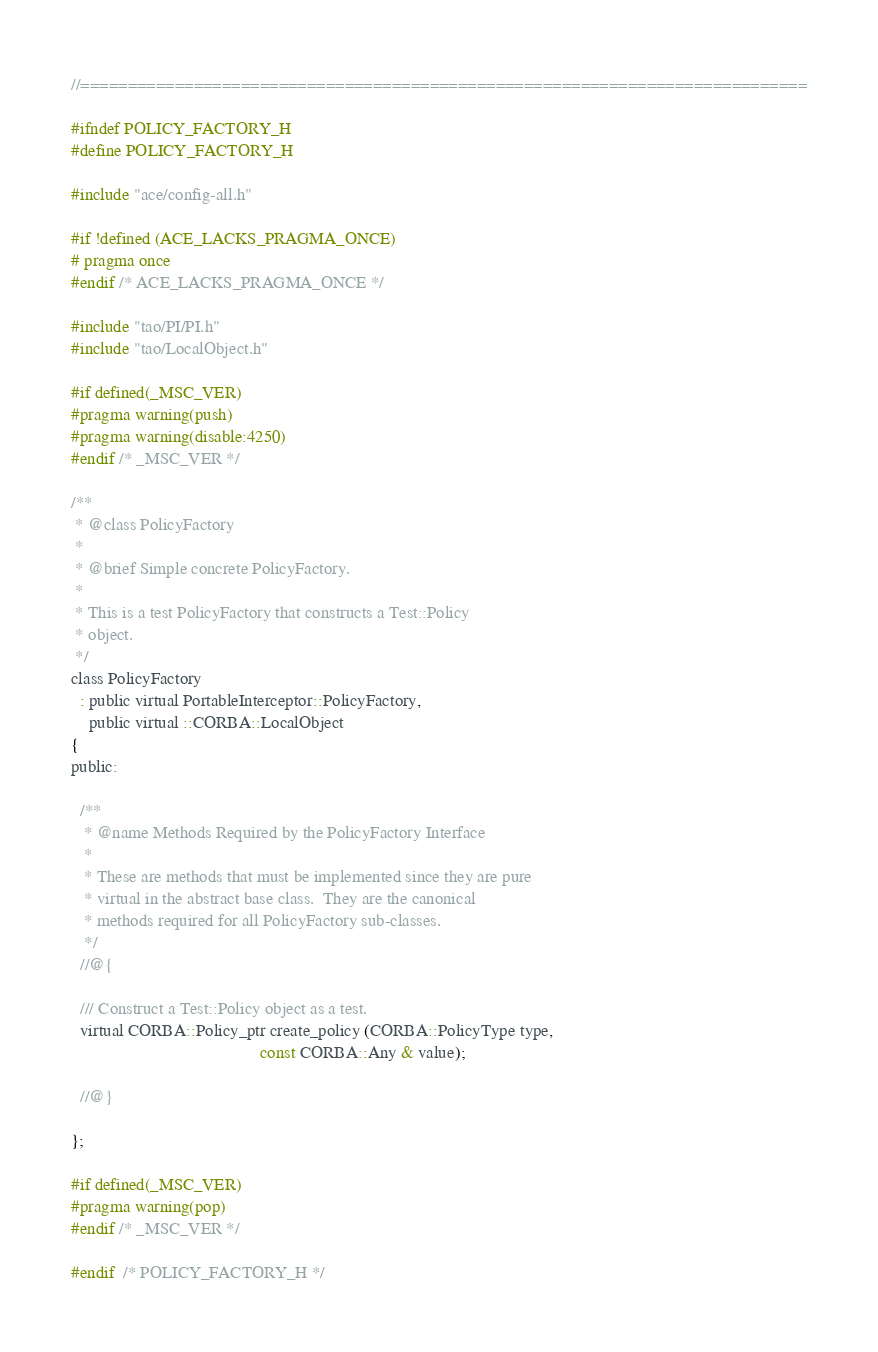<code> <loc_0><loc_0><loc_500><loc_500><_C_>//=============================================================================

#ifndef POLICY_FACTORY_H
#define POLICY_FACTORY_H

#include "ace/config-all.h"

#if !defined (ACE_LACKS_PRAGMA_ONCE)
# pragma once
#endif /* ACE_LACKS_PRAGMA_ONCE */

#include "tao/PI/PI.h"
#include "tao/LocalObject.h"

#if defined(_MSC_VER)
#pragma warning(push)
#pragma warning(disable:4250)
#endif /* _MSC_VER */

/**
 * @class PolicyFactory
 *
 * @brief Simple concrete PolicyFactory.
 *
 * This is a test PolicyFactory that constructs a Test::Policy
 * object.
 */
class PolicyFactory
  : public virtual PortableInterceptor::PolicyFactory,
    public virtual ::CORBA::LocalObject
{
public:

  /**
   * @name Methods Required by the PolicyFactory Interface
   *
   * These are methods that must be implemented since they are pure
   * virtual in the abstract base class.  They are the canonical
   * methods required for all PolicyFactory sub-classes.
   */
  //@{

  /// Construct a Test::Policy object as a test.
  virtual CORBA::Policy_ptr create_policy (CORBA::PolicyType type,
                                           const CORBA::Any & value);

  //@}

};

#if defined(_MSC_VER)
#pragma warning(pop)
#endif /* _MSC_VER */

#endif  /* POLICY_FACTORY_H */
</code> 